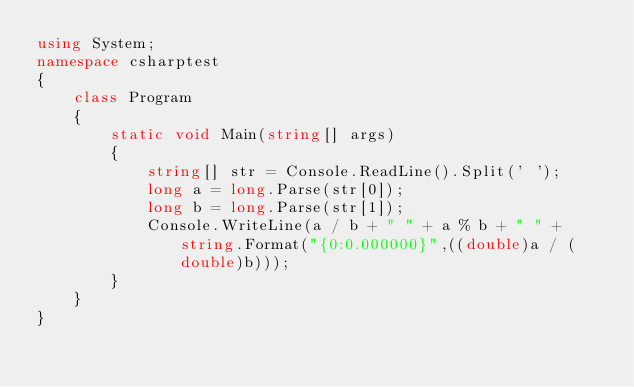<code> <loc_0><loc_0><loc_500><loc_500><_C#_>using System;
namespace csharptest
{
    class Program
    {
        static void Main(string[] args)
        {
            string[] str = Console.ReadLine().Split(' ');
            long a = long.Parse(str[0]);
            long b = long.Parse(str[1]);
            Console.WriteLine(a / b + " " + a % b + " " + string.Format("{0:0.000000}",((double)a / (double)b)));
        }
    }
}</code> 